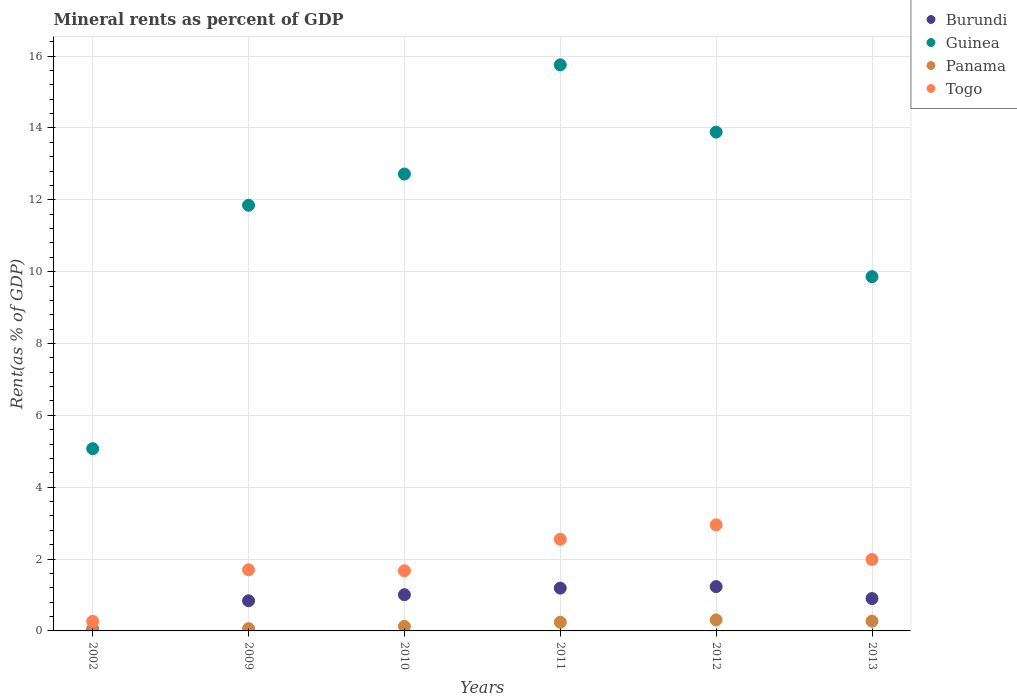What is the mineral rent in Burundi in 2010?
Make the answer very short. 1.01. Across all years, what is the maximum mineral rent in Togo?
Keep it short and to the point. 2.95. Across all years, what is the minimum mineral rent in Togo?
Your answer should be compact. 0.27. What is the total mineral rent in Togo in the graph?
Provide a succinct answer. 11.14. What is the difference between the mineral rent in Panama in 2009 and that in 2012?
Offer a terse response. -0.24. What is the difference between the mineral rent in Panama in 2011 and the mineral rent in Guinea in 2002?
Keep it short and to the point. -4.83. What is the average mineral rent in Guinea per year?
Your answer should be compact. 11.52. In the year 2013, what is the difference between the mineral rent in Panama and mineral rent in Guinea?
Give a very brief answer. -9.59. What is the ratio of the mineral rent in Panama in 2002 to that in 2012?
Your answer should be compact. 0.06. Is the mineral rent in Panama in 2009 less than that in 2013?
Keep it short and to the point. Yes. Is the difference between the mineral rent in Panama in 2009 and 2011 greater than the difference between the mineral rent in Guinea in 2009 and 2011?
Keep it short and to the point. Yes. What is the difference between the highest and the second highest mineral rent in Guinea?
Give a very brief answer. 1.87. What is the difference between the highest and the lowest mineral rent in Togo?
Provide a short and direct response. 2.68. In how many years, is the mineral rent in Guinea greater than the average mineral rent in Guinea taken over all years?
Keep it short and to the point. 4. Is it the case that in every year, the sum of the mineral rent in Togo and mineral rent in Guinea  is greater than the sum of mineral rent in Panama and mineral rent in Burundi?
Give a very brief answer. No. Is it the case that in every year, the sum of the mineral rent in Panama and mineral rent in Guinea  is greater than the mineral rent in Burundi?
Provide a succinct answer. Yes. Does the mineral rent in Panama monotonically increase over the years?
Make the answer very short. No. How many dotlines are there?
Provide a short and direct response. 4. How many years are there in the graph?
Your response must be concise. 6. What is the difference between two consecutive major ticks on the Y-axis?
Make the answer very short. 2. Are the values on the major ticks of Y-axis written in scientific E-notation?
Provide a succinct answer. No. How many legend labels are there?
Your answer should be compact. 4. How are the legend labels stacked?
Provide a short and direct response. Vertical. What is the title of the graph?
Your answer should be very brief. Mineral rents as percent of GDP. Does "Lao PDR" appear as one of the legend labels in the graph?
Make the answer very short. No. What is the label or title of the X-axis?
Give a very brief answer. Years. What is the label or title of the Y-axis?
Provide a succinct answer. Rent(as % of GDP). What is the Rent(as % of GDP) of Burundi in 2002?
Your response must be concise. 0.04. What is the Rent(as % of GDP) in Guinea in 2002?
Your response must be concise. 5.07. What is the Rent(as % of GDP) in Panama in 2002?
Your answer should be very brief. 0.02. What is the Rent(as % of GDP) of Togo in 2002?
Keep it short and to the point. 0.27. What is the Rent(as % of GDP) in Burundi in 2009?
Your response must be concise. 0.84. What is the Rent(as % of GDP) of Guinea in 2009?
Provide a succinct answer. 11.85. What is the Rent(as % of GDP) in Panama in 2009?
Ensure brevity in your answer.  0.06. What is the Rent(as % of GDP) of Togo in 2009?
Your answer should be very brief. 1.7. What is the Rent(as % of GDP) of Burundi in 2010?
Keep it short and to the point. 1.01. What is the Rent(as % of GDP) of Guinea in 2010?
Make the answer very short. 12.72. What is the Rent(as % of GDP) of Panama in 2010?
Offer a terse response. 0.13. What is the Rent(as % of GDP) in Togo in 2010?
Make the answer very short. 1.67. What is the Rent(as % of GDP) in Burundi in 2011?
Offer a terse response. 1.19. What is the Rent(as % of GDP) of Guinea in 2011?
Offer a terse response. 15.76. What is the Rent(as % of GDP) of Panama in 2011?
Your answer should be compact. 0.24. What is the Rent(as % of GDP) of Togo in 2011?
Ensure brevity in your answer.  2.55. What is the Rent(as % of GDP) of Burundi in 2012?
Offer a terse response. 1.23. What is the Rent(as % of GDP) in Guinea in 2012?
Your answer should be very brief. 13.88. What is the Rent(as % of GDP) in Panama in 2012?
Offer a very short reply. 0.31. What is the Rent(as % of GDP) of Togo in 2012?
Provide a succinct answer. 2.95. What is the Rent(as % of GDP) in Burundi in 2013?
Ensure brevity in your answer.  0.9. What is the Rent(as % of GDP) in Guinea in 2013?
Provide a succinct answer. 9.86. What is the Rent(as % of GDP) of Panama in 2013?
Provide a short and direct response. 0.27. What is the Rent(as % of GDP) of Togo in 2013?
Provide a short and direct response. 1.99. Across all years, what is the maximum Rent(as % of GDP) of Burundi?
Your answer should be very brief. 1.23. Across all years, what is the maximum Rent(as % of GDP) in Guinea?
Make the answer very short. 15.76. Across all years, what is the maximum Rent(as % of GDP) in Panama?
Give a very brief answer. 0.31. Across all years, what is the maximum Rent(as % of GDP) of Togo?
Provide a short and direct response. 2.95. Across all years, what is the minimum Rent(as % of GDP) of Burundi?
Make the answer very short. 0.04. Across all years, what is the minimum Rent(as % of GDP) in Guinea?
Give a very brief answer. 5.07. Across all years, what is the minimum Rent(as % of GDP) of Panama?
Make the answer very short. 0.02. Across all years, what is the minimum Rent(as % of GDP) in Togo?
Provide a short and direct response. 0.27. What is the total Rent(as % of GDP) in Burundi in the graph?
Your answer should be compact. 5.21. What is the total Rent(as % of GDP) of Guinea in the graph?
Make the answer very short. 69.14. What is the total Rent(as % of GDP) in Panama in the graph?
Provide a succinct answer. 1.03. What is the total Rent(as % of GDP) in Togo in the graph?
Offer a very short reply. 11.14. What is the difference between the Rent(as % of GDP) of Burundi in 2002 and that in 2009?
Offer a very short reply. -0.8. What is the difference between the Rent(as % of GDP) in Guinea in 2002 and that in 2009?
Give a very brief answer. -6.78. What is the difference between the Rent(as % of GDP) in Panama in 2002 and that in 2009?
Your answer should be compact. -0.04. What is the difference between the Rent(as % of GDP) in Togo in 2002 and that in 2009?
Offer a very short reply. -1.43. What is the difference between the Rent(as % of GDP) in Burundi in 2002 and that in 2010?
Your answer should be very brief. -0.97. What is the difference between the Rent(as % of GDP) in Guinea in 2002 and that in 2010?
Ensure brevity in your answer.  -7.65. What is the difference between the Rent(as % of GDP) in Panama in 2002 and that in 2010?
Keep it short and to the point. -0.11. What is the difference between the Rent(as % of GDP) of Togo in 2002 and that in 2010?
Ensure brevity in your answer.  -1.41. What is the difference between the Rent(as % of GDP) in Burundi in 2002 and that in 2011?
Keep it short and to the point. -1.15. What is the difference between the Rent(as % of GDP) of Guinea in 2002 and that in 2011?
Your answer should be very brief. -10.68. What is the difference between the Rent(as % of GDP) of Panama in 2002 and that in 2011?
Your answer should be very brief. -0.22. What is the difference between the Rent(as % of GDP) in Togo in 2002 and that in 2011?
Your answer should be compact. -2.28. What is the difference between the Rent(as % of GDP) of Burundi in 2002 and that in 2012?
Offer a terse response. -1.19. What is the difference between the Rent(as % of GDP) of Guinea in 2002 and that in 2012?
Give a very brief answer. -8.81. What is the difference between the Rent(as % of GDP) in Panama in 2002 and that in 2012?
Provide a succinct answer. -0.29. What is the difference between the Rent(as % of GDP) in Togo in 2002 and that in 2012?
Ensure brevity in your answer.  -2.68. What is the difference between the Rent(as % of GDP) of Burundi in 2002 and that in 2013?
Your response must be concise. -0.86. What is the difference between the Rent(as % of GDP) of Guinea in 2002 and that in 2013?
Make the answer very short. -4.79. What is the difference between the Rent(as % of GDP) of Panama in 2002 and that in 2013?
Offer a terse response. -0.25. What is the difference between the Rent(as % of GDP) of Togo in 2002 and that in 2013?
Provide a short and direct response. -1.72. What is the difference between the Rent(as % of GDP) of Burundi in 2009 and that in 2010?
Make the answer very short. -0.17. What is the difference between the Rent(as % of GDP) of Guinea in 2009 and that in 2010?
Give a very brief answer. -0.87. What is the difference between the Rent(as % of GDP) in Panama in 2009 and that in 2010?
Your answer should be compact. -0.06. What is the difference between the Rent(as % of GDP) in Togo in 2009 and that in 2010?
Offer a terse response. 0.03. What is the difference between the Rent(as % of GDP) in Burundi in 2009 and that in 2011?
Your response must be concise. -0.35. What is the difference between the Rent(as % of GDP) of Guinea in 2009 and that in 2011?
Offer a terse response. -3.91. What is the difference between the Rent(as % of GDP) of Panama in 2009 and that in 2011?
Your answer should be compact. -0.18. What is the difference between the Rent(as % of GDP) in Togo in 2009 and that in 2011?
Ensure brevity in your answer.  -0.85. What is the difference between the Rent(as % of GDP) of Burundi in 2009 and that in 2012?
Ensure brevity in your answer.  -0.39. What is the difference between the Rent(as % of GDP) in Guinea in 2009 and that in 2012?
Provide a succinct answer. -2.04. What is the difference between the Rent(as % of GDP) of Panama in 2009 and that in 2012?
Your answer should be very brief. -0.24. What is the difference between the Rent(as % of GDP) in Togo in 2009 and that in 2012?
Offer a very short reply. -1.25. What is the difference between the Rent(as % of GDP) of Burundi in 2009 and that in 2013?
Your response must be concise. -0.06. What is the difference between the Rent(as % of GDP) of Guinea in 2009 and that in 2013?
Ensure brevity in your answer.  1.99. What is the difference between the Rent(as % of GDP) of Panama in 2009 and that in 2013?
Provide a short and direct response. -0.21. What is the difference between the Rent(as % of GDP) of Togo in 2009 and that in 2013?
Make the answer very short. -0.29. What is the difference between the Rent(as % of GDP) in Burundi in 2010 and that in 2011?
Your response must be concise. -0.18. What is the difference between the Rent(as % of GDP) of Guinea in 2010 and that in 2011?
Offer a terse response. -3.04. What is the difference between the Rent(as % of GDP) in Panama in 2010 and that in 2011?
Your answer should be very brief. -0.11. What is the difference between the Rent(as % of GDP) in Togo in 2010 and that in 2011?
Provide a short and direct response. -0.88. What is the difference between the Rent(as % of GDP) of Burundi in 2010 and that in 2012?
Your response must be concise. -0.23. What is the difference between the Rent(as % of GDP) in Guinea in 2010 and that in 2012?
Give a very brief answer. -1.17. What is the difference between the Rent(as % of GDP) of Panama in 2010 and that in 2012?
Give a very brief answer. -0.18. What is the difference between the Rent(as % of GDP) in Togo in 2010 and that in 2012?
Your response must be concise. -1.28. What is the difference between the Rent(as % of GDP) in Burundi in 2010 and that in 2013?
Offer a terse response. 0.11. What is the difference between the Rent(as % of GDP) of Guinea in 2010 and that in 2013?
Your answer should be compact. 2.86. What is the difference between the Rent(as % of GDP) of Panama in 2010 and that in 2013?
Offer a very short reply. -0.14. What is the difference between the Rent(as % of GDP) of Togo in 2010 and that in 2013?
Your answer should be very brief. -0.31. What is the difference between the Rent(as % of GDP) of Burundi in 2011 and that in 2012?
Your answer should be very brief. -0.04. What is the difference between the Rent(as % of GDP) in Guinea in 2011 and that in 2012?
Offer a very short reply. 1.87. What is the difference between the Rent(as % of GDP) in Panama in 2011 and that in 2012?
Ensure brevity in your answer.  -0.06. What is the difference between the Rent(as % of GDP) of Togo in 2011 and that in 2012?
Your answer should be compact. -0.4. What is the difference between the Rent(as % of GDP) in Burundi in 2011 and that in 2013?
Ensure brevity in your answer.  0.29. What is the difference between the Rent(as % of GDP) in Guinea in 2011 and that in 2013?
Keep it short and to the point. 5.89. What is the difference between the Rent(as % of GDP) of Panama in 2011 and that in 2013?
Ensure brevity in your answer.  -0.03. What is the difference between the Rent(as % of GDP) in Togo in 2011 and that in 2013?
Keep it short and to the point. 0.56. What is the difference between the Rent(as % of GDP) of Burundi in 2012 and that in 2013?
Your answer should be very brief. 0.33. What is the difference between the Rent(as % of GDP) of Guinea in 2012 and that in 2013?
Offer a very short reply. 4.02. What is the difference between the Rent(as % of GDP) in Panama in 2012 and that in 2013?
Offer a very short reply. 0.03. What is the difference between the Rent(as % of GDP) in Togo in 2012 and that in 2013?
Offer a terse response. 0.96. What is the difference between the Rent(as % of GDP) of Burundi in 2002 and the Rent(as % of GDP) of Guinea in 2009?
Offer a terse response. -11.81. What is the difference between the Rent(as % of GDP) in Burundi in 2002 and the Rent(as % of GDP) in Panama in 2009?
Provide a succinct answer. -0.02. What is the difference between the Rent(as % of GDP) in Burundi in 2002 and the Rent(as % of GDP) in Togo in 2009?
Provide a succinct answer. -1.66. What is the difference between the Rent(as % of GDP) in Guinea in 2002 and the Rent(as % of GDP) in Panama in 2009?
Provide a succinct answer. 5.01. What is the difference between the Rent(as % of GDP) of Guinea in 2002 and the Rent(as % of GDP) of Togo in 2009?
Offer a terse response. 3.37. What is the difference between the Rent(as % of GDP) of Panama in 2002 and the Rent(as % of GDP) of Togo in 2009?
Your answer should be very brief. -1.68. What is the difference between the Rent(as % of GDP) in Burundi in 2002 and the Rent(as % of GDP) in Guinea in 2010?
Offer a terse response. -12.68. What is the difference between the Rent(as % of GDP) of Burundi in 2002 and the Rent(as % of GDP) of Panama in 2010?
Provide a short and direct response. -0.09. What is the difference between the Rent(as % of GDP) of Burundi in 2002 and the Rent(as % of GDP) of Togo in 2010?
Your answer should be very brief. -1.63. What is the difference between the Rent(as % of GDP) in Guinea in 2002 and the Rent(as % of GDP) in Panama in 2010?
Make the answer very short. 4.94. What is the difference between the Rent(as % of GDP) of Guinea in 2002 and the Rent(as % of GDP) of Togo in 2010?
Keep it short and to the point. 3.4. What is the difference between the Rent(as % of GDP) in Panama in 2002 and the Rent(as % of GDP) in Togo in 2010?
Offer a terse response. -1.66. What is the difference between the Rent(as % of GDP) in Burundi in 2002 and the Rent(as % of GDP) in Guinea in 2011?
Provide a short and direct response. -15.71. What is the difference between the Rent(as % of GDP) of Burundi in 2002 and the Rent(as % of GDP) of Panama in 2011?
Offer a terse response. -0.2. What is the difference between the Rent(as % of GDP) in Burundi in 2002 and the Rent(as % of GDP) in Togo in 2011?
Your answer should be very brief. -2.51. What is the difference between the Rent(as % of GDP) of Guinea in 2002 and the Rent(as % of GDP) of Panama in 2011?
Offer a very short reply. 4.83. What is the difference between the Rent(as % of GDP) of Guinea in 2002 and the Rent(as % of GDP) of Togo in 2011?
Provide a short and direct response. 2.52. What is the difference between the Rent(as % of GDP) of Panama in 2002 and the Rent(as % of GDP) of Togo in 2011?
Your response must be concise. -2.53. What is the difference between the Rent(as % of GDP) in Burundi in 2002 and the Rent(as % of GDP) in Guinea in 2012?
Your answer should be compact. -13.84. What is the difference between the Rent(as % of GDP) in Burundi in 2002 and the Rent(as % of GDP) in Panama in 2012?
Provide a succinct answer. -0.26. What is the difference between the Rent(as % of GDP) in Burundi in 2002 and the Rent(as % of GDP) in Togo in 2012?
Your response must be concise. -2.91. What is the difference between the Rent(as % of GDP) of Guinea in 2002 and the Rent(as % of GDP) of Panama in 2012?
Provide a succinct answer. 4.77. What is the difference between the Rent(as % of GDP) in Guinea in 2002 and the Rent(as % of GDP) in Togo in 2012?
Ensure brevity in your answer.  2.12. What is the difference between the Rent(as % of GDP) of Panama in 2002 and the Rent(as % of GDP) of Togo in 2012?
Offer a terse response. -2.93. What is the difference between the Rent(as % of GDP) of Burundi in 2002 and the Rent(as % of GDP) of Guinea in 2013?
Provide a short and direct response. -9.82. What is the difference between the Rent(as % of GDP) of Burundi in 2002 and the Rent(as % of GDP) of Panama in 2013?
Provide a short and direct response. -0.23. What is the difference between the Rent(as % of GDP) in Burundi in 2002 and the Rent(as % of GDP) in Togo in 2013?
Provide a succinct answer. -1.95. What is the difference between the Rent(as % of GDP) of Guinea in 2002 and the Rent(as % of GDP) of Panama in 2013?
Make the answer very short. 4.8. What is the difference between the Rent(as % of GDP) of Guinea in 2002 and the Rent(as % of GDP) of Togo in 2013?
Your response must be concise. 3.08. What is the difference between the Rent(as % of GDP) in Panama in 2002 and the Rent(as % of GDP) in Togo in 2013?
Ensure brevity in your answer.  -1.97. What is the difference between the Rent(as % of GDP) of Burundi in 2009 and the Rent(as % of GDP) of Guinea in 2010?
Make the answer very short. -11.88. What is the difference between the Rent(as % of GDP) in Burundi in 2009 and the Rent(as % of GDP) in Panama in 2010?
Your answer should be compact. 0.71. What is the difference between the Rent(as % of GDP) of Burundi in 2009 and the Rent(as % of GDP) of Togo in 2010?
Offer a very short reply. -0.83. What is the difference between the Rent(as % of GDP) of Guinea in 2009 and the Rent(as % of GDP) of Panama in 2010?
Offer a very short reply. 11.72. What is the difference between the Rent(as % of GDP) of Guinea in 2009 and the Rent(as % of GDP) of Togo in 2010?
Give a very brief answer. 10.17. What is the difference between the Rent(as % of GDP) of Panama in 2009 and the Rent(as % of GDP) of Togo in 2010?
Ensure brevity in your answer.  -1.61. What is the difference between the Rent(as % of GDP) in Burundi in 2009 and the Rent(as % of GDP) in Guinea in 2011?
Make the answer very short. -14.92. What is the difference between the Rent(as % of GDP) in Burundi in 2009 and the Rent(as % of GDP) in Panama in 2011?
Your response must be concise. 0.6. What is the difference between the Rent(as % of GDP) in Burundi in 2009 and the Rent(as % of GDP) in Togo in 2011?
Provide a short and direct response. -1.71. What is the difference between the Rent(as % of GDP) in Guinea in 2009 and the Rent(as % of GDP) in Panama in 2011?
Your answer should be compact. 11.61. What is the difference between the Rent(as % of GDP) of Guinea in 2009 and the Rent(as % of GDP) of Togo in 2011?
Offer a very short reply. 9.3. What is the difference between the Rent(as % of GDP) in Panama in 2009 and the Rent(as % of GDP) in Togo in 2011?
Ensure brevity in your answer.  -2.49. What is the difference between the Rent(as % of GDP) in Burundi in 2009 and the Rent(as % of GDP) in Guinea in 2012?
Provide a short and direct response. -13.04. What is the difference between the Rent(as % of GDP) in Burundi in 2009 and the Rent(as % of GDP) in Panama in 2012?
Your answer should be compact. 0.53. What is the difference between the Rent(as % of GDP) of Burundi in 2009 and the Rent(as % of GDP) of Togo in 2012?
Your answer should be compact. -2.11. What is the difference between the Rent(as % of GDP) in Guinea in 2009 and the Rent(as % of GDP) in Panama in 2012?
Your answer should be very brief. 11.54. What is the difference between the Rent(as % of GDP) in Guinea in 2009 and the Rent(as % of GDP) in Togo in 2012?
Ensure brevity in your answer.  8.89. What is the difference between the Rent(as % of GDP) in Panama in 2009 and the Rent(as % of GDP) in Togo in 2012?
Offer a very short reply. -2.89. What is the difference between the Rent(as % of GDP) of Burundi in 2009 and the Rent(as % of GDP) of Guinea in 2013?
Your answer should be compact. -9.02. What is the difference between the Rent(as % of GDP) in Burundi in 2009 and the Rent(as % of GDP) in Panama in 2013?
Make the answer very short. 0.57. What is the difference between the Rent(as % of GDP) of Burundi in 2009 and the Rent(as % of GDP) of Togo in 2013?
Your response must be concise. -1.15. What is the difference between the Rent(as % of GDP) in Guinea in 2009 and the Rent(as % of GDP) in Panama in 2013?
Your response must be concise. 11.57. What is the difference between the Rent(as % of GDP) in Guinea in 2009 and the Rent(as % of GDP) in Togo in 2013?
Give a very brief answer. 9.86. What is the difference between the Rent(as % of GDP) of Panama in 2009 and the Rent(as % of GDP) of Togo in 2013?
Offer a terse response. -1.93. What is the difference between the Rent(as % of GDP) in Burundi in 2010 and the Rent(as % of GDP) in Guinea in 2011?
Offer a terse response. -14.75. What is the difference between the Rent(as % of GDP) in Burundi in 2010 and the Rent(as % of GDP) in Panama in 2011?
Your response must be concise. 0.77. What is the difference between the Rent(as % of GDP) of Burundi in 2010 and the Rent(as % of GDP) of Togo in 2011?
Offer a terse response. -1.54. What is the difference between the Rent(as % of GDP) of Guinea in 2010 and the Rent(as % of GDP) of Panama in 2011?
Your answer should be very brief. 12.47. What is the difference between the Rent(as % of GDP) in Guinea in 2010 and the Rent(as % of GDP) in Togo in 2011?
Your answer should be compact. 10.17. What is the difference between the Rent(as % of GDP) of Panama in 2010 and the Rent(as % of GDP) of Togo in 2011?
Make the answer very short. -2.42. What is the difference between the Rent(as % of GDP) in Burundi in 2010 and the Rent(as % of GDP) in Guinea in 2012?
Provide a short and direct response. -12.88. What is the difference between the Rent(as % of GDP) of Burundi in 2010 and the Rent(as % of GDP) of Panama in 2012?
Offer a very short reply. 0.7. What is the difference between the Rent(as % of GDP) of Burundi in 2010 and the Rent(as % of GDP) of Togo in 2012?
Keep it short and to the point. -1.95. What is the difference between the Rent(as % of GDP) in Guinea in 2010 and the Rent(as % of GDP) in Panama in 2012?
Provide a short and direct response. 12.41. What is the difference between the Rent(as % of GDP) of Guinea in 2010 and the Rent(as % of GDP) of Togo in 2012?
Keep it short and to the point. 9.76. What is the difference between the Rent(as % of GDP) of Panama in 2010 and the Rent(as % of GDP) of Togo in 2012?
Provide a short and direct response. -2.83. What is the difference between the Rent(as % of GDP) of Burundi in 2010 and the Rent(as % of GDP) of Guinea in 2013?
Provide a succinct answer. -8.85. What is the difference between the Rent(as % of GDP) in Burundi in 2010 and the Rent(as % of GDP) in Panama in 2013?
Ensure brevity in your answer.  0.73. What is the difference between the Rent(as % of GDP) in Burundi in 2010 and the Rent(as % of GDP) in Togo in 2013?
Make the answer very short. -0.98. What is the difference between the Rent(as % of GDP) in Guinea in 2010 and the Rent(as % of GDP) in Panama in 2013?
Keep it short and to the point. 12.44. What is the difference between the Rent(as % of GDP) in Guinea in 2010 and the Rent(as % of GDP) in Togo in 2013?
Keep it short and to the point. 10.73. What is the difference between the Rent(as % of GDP) of Panama in 2010 and the Rent(as % of GDP) of Togo in 2013?
Ensure brevity in your answer.  -1.86. What is the difference between the Rent(as % of GDP) of Burundi in 2011 and the Rent(as % of GDP) of Guinea in 2012?
Your answer should be compact. -12.69. What is the difference between the Rent(as % of GDP) of Burundi in 2011 and the Rent(as % of GDP) of Panama in 2012?
Give a very brief answer. 0.89. What is the difference between the Rent(as % of GDP) of Burundi in 2011 and the Rent(as % of GDP) of Togo in 2012?
Provide a succinct answer. -1.76. What is the difference between the Rent(as % of GDP) of Guinea in 2011 and the Rent(as % of GDP) of Panama in 2012?
Ensure brevity in your answer.  15.45. What is the difference between the Rent(as % of GDP) in Guinea in 2011 and the Rent(as % of GDP) in Togo in 2012?
Your answer should be very brief. 12.8. What is the difference between the Rent(as % of GDP) in Panama in 2011 and the Rent(as % of GDP) in Togo in 2012?
Your answer should be very brief. -2.71. What is the difference between the Rent(as % of GDP) of Burundi in 2011 and the Rent(as % of GDP) of Guinea in 2013?
Offer a very short reply. -8.67. What is the difference between the Rent(as % of GDP) in Burundi in 2011 and the Rent(as % of GDP) in Panama in 2013?
Ensure brevity in your answer.  0.92. What is the difference between the Rent(as % of GDP) of Burundi in 2011 and the Rent(as % of GDP) of Togo in 2013?
Your response must be concise. -0.8. What is the difference between the Rent(as % of GDP) in Guinea in 2011 and the Rent(as % of GDP) in Panama in 2013?
Ensure brevity in your answer.  15.48. What is the difference between the Rent(as % of GDP) in Guinea in 2011 and the Rent(as % of GDP) in Togo in 2013?
Offer a terse response. 13.77. What is the difference between the Rent(as % of GDP) of Panama in 2011 and the Rent(as % of GDP) of Togo in 2013?
Make the answer very short. -1.75. What is the difference between the Rent(as % of GDP) in Burundi in 2012 and the Rent(as % of GDP) in Guinea in 2013?
Your response must be concise. -8.63. What is the difference between the Rent(as % of GDP) in Burundi in 2012 and the Rent(as % of GDP) in Togo in 2013?
Provide a short and direct response. -0.76. What is the difference between the Rent(as % of GDP) in Guinea in 2012 and the Rent(as % of GDP) in Panama in 2013?
Your answer should be compact. 13.61. What is the difference between the Rent(as % of GDP) of Guinea in 2012 and the Rent(as % of GDP) of Togo in 2013?
Provide a short and direct response. 11.89. What is the difference between the Rent(as % of GDP) in Panama in 2012 and the Rent(as % of GDP) in Togo in 2013?
Provide a succinct answer. -1.68. What is the average Rent(as % of GDP) in Burundi per year?
Provide a succinct answer. 0.87. What is the average Rent(as % of GDP) of Guinea per year?
Provide a short and direct response. 11.52. What is the average Rent(as % of GDP) of Panama per year?
Provide a short and direct response. 0.17. What is the average Rent(as % of GDP) of Togo per year?
Your response must be concise. 1.86. In the year 2002, what is the difference between the Rent(as % of GDP) in Burundi and Rent(as % of GDP) in Guinea?
Your answer should be compact. -5.03. In the year 2002, what is the difference between the Rent(as % of GDP) of Burundi and Rent(as % of GDP) of Panama?
Offer a very short reply. 0.02. In the year 2002, what is the difference between the Rent(as % of GDP) of Burundi and Rent(as % of GDP) of Togo?
Offer a terse response. -0.23. In the year 2002, what is the difference between the Rent(as % of GDP) of Guinea and Rent(as % of GDP) of Panama?
Provide a short and direct response. 5.05. In the year 2002, what is the difference between the Rent(as % of GDP) of Guinea and Rent(as % of GDP) of Togo?
Your answer should be very brief. 4.8. In the year 2002, what is the difference between the Rent(as % of GDP) in Panama and Rent(as % of GDP) in Togo?
Your answer should be compact. -0.25. In the year 2009, what is the difference between the Rent(as % of GDP) of Burundi and Rent(as % of GDP) of Guinea?
Ensure brevity in your answer.  -11.01. In the year 2009, what is the difference between the Rent(as % of GDP) of Burundi and Rent(as % of GDP) of Panama?
Your answer should be very brief. 0.78. In the year 2009, what is the difference between the Rent(as % of GDP) of Burundi and Rent(as % of GDP) of Togo?
Ensure brevity in your answer.  -0.86. In the year 2009, what is the difference between the Rent(as % of GDP) of Guinea and Rent(as % of GDP) of Panama?
Give a very brief answer. 11.78. In the year 2009, what is the difference between the Rent(as % of GDP) in Guinea and Rent(as % of GDP) in Togo?
Make the answer very short. 10.15. In the year 2009, what is the difference between the Rent(as % of GDP) in Panama and Rent(as % of GDP) in Togo?
Ensure brevity in your answer.  -1.64. In the year 2010, what is the difference between the Rent(as % of GDP) of Burundi and Rent(as % of GDP) of Guinea?
Provide a succinct answer. -11.71. In the year 2010, what is the difference between the Rent(as % of GDP) of Burundi and Rent(as % of GDP) of Panama?
Your answer should be compact. 0.88. In the year 2010, what is the difference between the Rent(as % of GDP) of Burundi and Rent(as % of GDP) of Togo?
Offer a terse response. -0.67. In the year 2010, what is the difference between the Rent(as % of GDP) of Guinea and Rent(as % of GDP) of Panama?
Provide a succinct answer. 12.59. In the year 2010, what is the difference between the Rent(as % of GDP) of Guinea and Rent(as % of GDP) of Togo?
Make the answer very short. 11.04. In the year 2010, what is the difference between the Rent(as % of GDP) in Panama and Rent(as % of GDP) in Togo?
Keep it short and to the point. -1.55. In the year 2011, what is the difference between the Rent(as % of GDP) of Burundi and Rent(as % of GDP) of Guinea?
Ensure brevity in your answer.  -14.56. In the year 2011, what is the difference between the Rent(as % of GDP) in Burundi and Rent(as % of GDP) in Panama?
Your answer should be compact. 0.95. In the year 2011, what is the difference between the Rent(as % of GDP) in Burundi and Rent(as % of GDP) in Togo?
Offer a terse response. -1.36. In the year 2011, what is the difference between the Rent(as % of GDP) in Guinea and Rent(as % of GDP) in Panama?
Your answer should be very brief. 15.51. In the year 2011, what is the difference between the Rent(as % of GDP) in Guinea and Rent(as % of GDP) in Togo?
Make the answer very short. 13.2. In the year 2011, what is the difference between the Rent(as % of GDP) of Panama and Rent(as % of GDP) of Togo?
Give a very brief answer. -2.31. In the year 2012, what is the difference between the Rent(as % of GDP) in Burundi and Rent(as % of GDP) in Guinea?
Give a very brief answer. -12.65. In the year 2012, what is the difference between the Rent(as % of GDP) in Burundi and Rent(as % of GDP) in Panama?
Offer a terse response. 0.93. In the year 2012, what is the difference between the Rent(as % of GDP) in Burundi and Rent(as % of GDP) in Togo?
Your answer should be very brief. -1.72. In the year 2012, what is the difference between the Rent(as % of GDP) of Guinea and Rent(as % of GDP) of Panama?
Your answer should be compact. 13.58. In the year 2012, what is the difference between the Rent(as % of GDP) of Guinea and Rent(as % of GDP) of Togo?
Give a very brief answer. 10.93. In the year 2012, what is the difference between the Rent(as % of GDP) in Panama and Rent(as % of GDP) in Togo?
Give a very brief answer. -2.65. In the year 2013, what is the difference between the Rent(as % of GDP) of Burundi and Rent(as % of GDP) of Guinea?
Your response must be concise. -8.96. In the year 2013, what is the difference between the Rent(as % of GDP) of Burundi and Rent(as % of GDP) of Panama?
Ensure brevity in your answer.  0.63. In the year 2013, what is the difference between the Rent(as % of GDP) of Burundi and Rent(as % of GDP) of Togo?
Keep it short and to the point. -1.09. In the year 2013, what is the difference between the Rent(as % of GDP) of Guinea and Rent(as % of GDP) of Panama?
Offer a terse response. 9.59. In the year 2013, what is the difference between the Rent(as % of GDP) of Guinea and Rent(as % of GDP) of Togo?
Provide a succinct answer. 7.87. In the year 2013, what is the difference between the Rent(as % of GDP) of Panama and Rent(as % of GDP) of Togo?
Keep it short and to the point. -1.72. What is the ratio of the Rent(as % of GDP) of Burundi in 2002 to that in 2009?
Make the answer very short. 0.05. What is the ratio of the Rent(as % of GDP) of Guinea in 2002 to that in 2009?
Your answer should be compact. 0.43. What is the ratio of the Rent(as % of GDP) of Panama in 2002 to that in 2009?
Make the answer very short. 0.3. What is the ratio of the Rent(as % of GDP) of Togo in 2002 to that in 2009?
Provide a succinct answer. 0.16. What is the ratio of the Rent(as % of GDP) in Burundi in 2002 to that in 2010?
Give a very brief answer. 0.04. What is the ratio of the Rent(as % of GDP) of Guinea in 2002 to that in 2010?
Make the answer very short. 0.4. What is the ratio of the Rent(as % of GDP) in Panama in 2002 to that in 2010?
Your answer should be very brief. 0.15. What is the ratio of the Rent(as % of GDP) in Togo in 2002 to that in 2010?
Your answer should be very brief. 0.16. What is the ratio of the Rent(as % of GDP) of Burundi in 2002 to that in 2011?
Provide a succinct answer. 0.03. What is the ratio of the Rent(as % of GDP) of Guinea in 2002 to that in 2011?
Offer a terse response. 0.32. What is the ratio of the Rent(as % of GDP) of Panama in 2002 to that in 2011?
Give a very brief answer. 0.08. What is the ratio of the Rent(as % of GDP) in Togo in 2002 to that in 2011?
Provide a succinct answer. 0.1. What is the ratio of the Rent(as % of GDP) of Burundi in 2002 to that in 2012?
Your answer should be compact. 0.03. What is the ratio of the Rent(as % of GDP) in Guinea in 2002 to that in 2012?
Keep it short and to the point. 0.37. What is the ratio of the Rent(as % of GDP) of Panama in 2002 to that in 2012?
Ensure brevity in your answer.  0.06. What is the ratio of the Rent(as % of GDP) in Togo in 2002 to that in 2012?
Make the answer very short. 0.09. What is the ratio of the Rent(as % of GDP) of Burundi in 2002 to that in 2013?
Your response must be concise. 0.05. What is the ratio of the Rent(as % of GDP) in Guinea in 2002 to that in 2013?
Keep it short and to the point. 0.51. What is the ratio of the Rent(as % of GDP) of Panama in 2002 to that in 2013?
Provide a succinct answer. 0.07. What is the ratio of the Rent(as % of GDP) of Togo in 2002 to that in 2013?
Your answer should be very brief. 0.13. What is the ratio of the Rent(as % of GDP) in Burundi in 2009 to that in 2010?
Provide a short and direct response. 0.83. What is the ratio of the Rent(as % of GDP) in Guinea in 2009 to that in 2010?
Provide a short and direct response. 0.93. What is the ratio of the Rent(as % of GDP) in Panama in 2009 to that in 2010?
Offer a terse response. 0.5. What is the ratio of the Rent(as % of GDP) in Togo in 2009 to that in 2010?
Your answer should be compact. 1.02. What is the ratio of the Rent(as % of GDP) in Burundi in 2009 to that in 2011?
Ensure brevity in your answer.  0.7. What is the ratio of the Rent(as % of GDP) of Guinea in 2009 to that in 2011?
Ensure brevity in your answer.  0.75. What is the ratio of the Rent(as % of GDP) in Panama in 2009 to that in 2011?
Keep it short and to the point. 0.26. What is the ratio of the Rent(as % of GDP) in Togo in 2009 to that in 2011?
Your answer should be very brief. 0.67. What is the ratio of the Rent(as % of GDP) of Burundi in 2009 to that in 2012?
Your answer should be compact. 0.68. What is the ratio of the Rent(as % of GDP) of Guinea in 2009 to that in 2012?
Offer a very short reply. 0.85. What is the ratio of the Rent(as % of GDP) in Panama in 2009 to that in 2012?
Make the answer very short. 0.21. What is the ratio of the Rent(as % of GDP) of Togo in 2009 to that in 2012?
Your answer should be compact. 0.58. What is the ratio of the Rent(as % of GDP) of Burundi in 2009 to that in 2013?
Keep it short and to the point. 0.93. What is the ratio of the Rent(as % of GDP) of Guinea in 2009 to that in 2013?
Ensure brevity in your answer.  1.2. What is the ratio of the Rent(as % of GDP) of Panama in 2009 to that in 2013?
Offer a very short reply. 0.23. What is the ratio of the Rent(as % of GDP) in Togo in 2009 to that in 2013?
Provide a short and direct response. 0.86. What is the ratio of the Rent(as % of GDP) of Burundi in 2010 to that in 2011?
Your answer should be compact. 0.85. What is the ratio of the Rent(as % of GDP) in Guinea in 2010 to that in 2011?
Your answer should be compact. 0.81. What is the ratio of the Rent(as % of GDP) in Panama in 2010 to that in 2011?
Your response must be concise. 0.53. What is the ratio of the Rent(as % of GDP) of Togo in 2010 to that in 2011?
Ensure brevity in your answer.  0.66. What is the ratio of the Rent(as % of GDP) of Burundi in 2010 to that in 2012?
Ensure brevity in your answer.  0.82. What is the ratio of the Rent(as % of GDP) of Guinea in 2010 to that in 2012?
Your answer should be compact. 0.92. What is the ratio of the Rent(as % of GDP) of Panama in 2010 to that in 2012?
Your answer should be very brief. 0.42. What is the ratio of the Rent(as % of GDP) of Togo in 2010 to that in 2012?
Your answer should be compact. 0.57. What is the ratio of the Rent(as % of GDP) in Burundi in 2010 to that in 2013?
Your answer should be very brief. 1.12. What is the ratio of the Rent(as % of GDP) of Guinea in 2010 to that in 2013?
Offer a very short reply. 1.29. What is the ratio of the Rent(as % of GDP) in Panama in 2010 to that in 2013?
Keep it short and to the point. 0.47. What is the ratio of the Rent(as % of GDP) of Togo in 2010 to that in 2013?
Your answer should be very brief. 0.84. What is the ratio of the Rent(as % of GDP) of Burundi in 2011 to that in 2012?
Make the answer very short. 0.97. What is the ratio of the Rent(as % of GDP) of Guinea in 2011 to that in 2012?
Provide a short and direct response. 1.13. What is the ratio of the Rent(as % of GDP) in Panama in 2011 to that in 2012?
Make the answer very short. 0.79. What is the ratio of the Rent(as % of GDP) of Togo in 2011 to that in 2012?
Your response must be concise. 0.86. What is the ratio of the Rent(as % of GDP) in Burundi in 2011 to that in 2013?
Offer a terse response. 1.32. What is the ratio of the Rent(as % of GDP) in Guinea in 2011 to that in 2013?
Make the answer very short. 1.6. What is the ratio of the Rent(as % of GDP) of Panama in 2011 to that in 2013?
Your response must be concise. 0.89. What is the ratio of the Rent(as % of GDP) of Togo in 2011 to that in 2013?
Give a very brief answer. 1.28. What is the ratio of the Rent(as % of GDP) of Burundi in 2012 to that in 2013?
Ensure brevity in your answer.  1.37. What is the ratio of the Rent(as % of GDP) of Guinea in 2012 to that in 2013?
Offer a very short reply. 1.41. What is the ratio of the Rent(as % of GDP) of Panama in 2012 to that in 2013?
Ensure brevity in your answer.  1.12. What is the ratio of the Rent(as % of GDP) in Togo in 2012 to that in 2013?
Ensure brevity in your answer.  1.48. What is the difference between the highest and the second highest Rent(as % of GDP) of Burundi?
Your answer should be very brief. 0.04. What is the difference between the highest and the second highest Rent(as % of GDP) of Guinea?
Provide a succinct answer. 1.87. What is the difference between the highest and the second highest Rent(as % of GDP) in Panama?
Give a very brief answer. 0.03. What is the difference between the highest and the second highest Rent(as % of GDP) of Togo?
Your answer should be very brief. 0.4. What is the difference between the highest and the lowest Rent(as % of GDP) of Burundi?
Give a very brief answer. 1.19. What is the difference between the highest and the lowest Rent(as % of GDP) of Guinea?
Give a very brief answer. 10.68. What is the difference between the highest and the lowest Rent(as % of GDP) in Panama?
Provide a short and direct response. 0.29. What is the difference between the highest and the lowest Rent(as % of GDP) of Togo?
Your response must be concise. 2.68. 